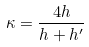<formula> <loc_0><loc_0><loc_500><loc_500>\kappa = \frac { 4 h } { h + h ^ { \prime } }</formula> 